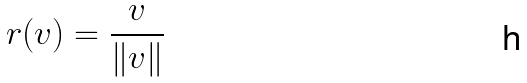Convert formula to latex. <formula><loc_0><loc_0><loc_500><loc_500>r ( v ) = \frac { v } { \| v \| }</formula> 